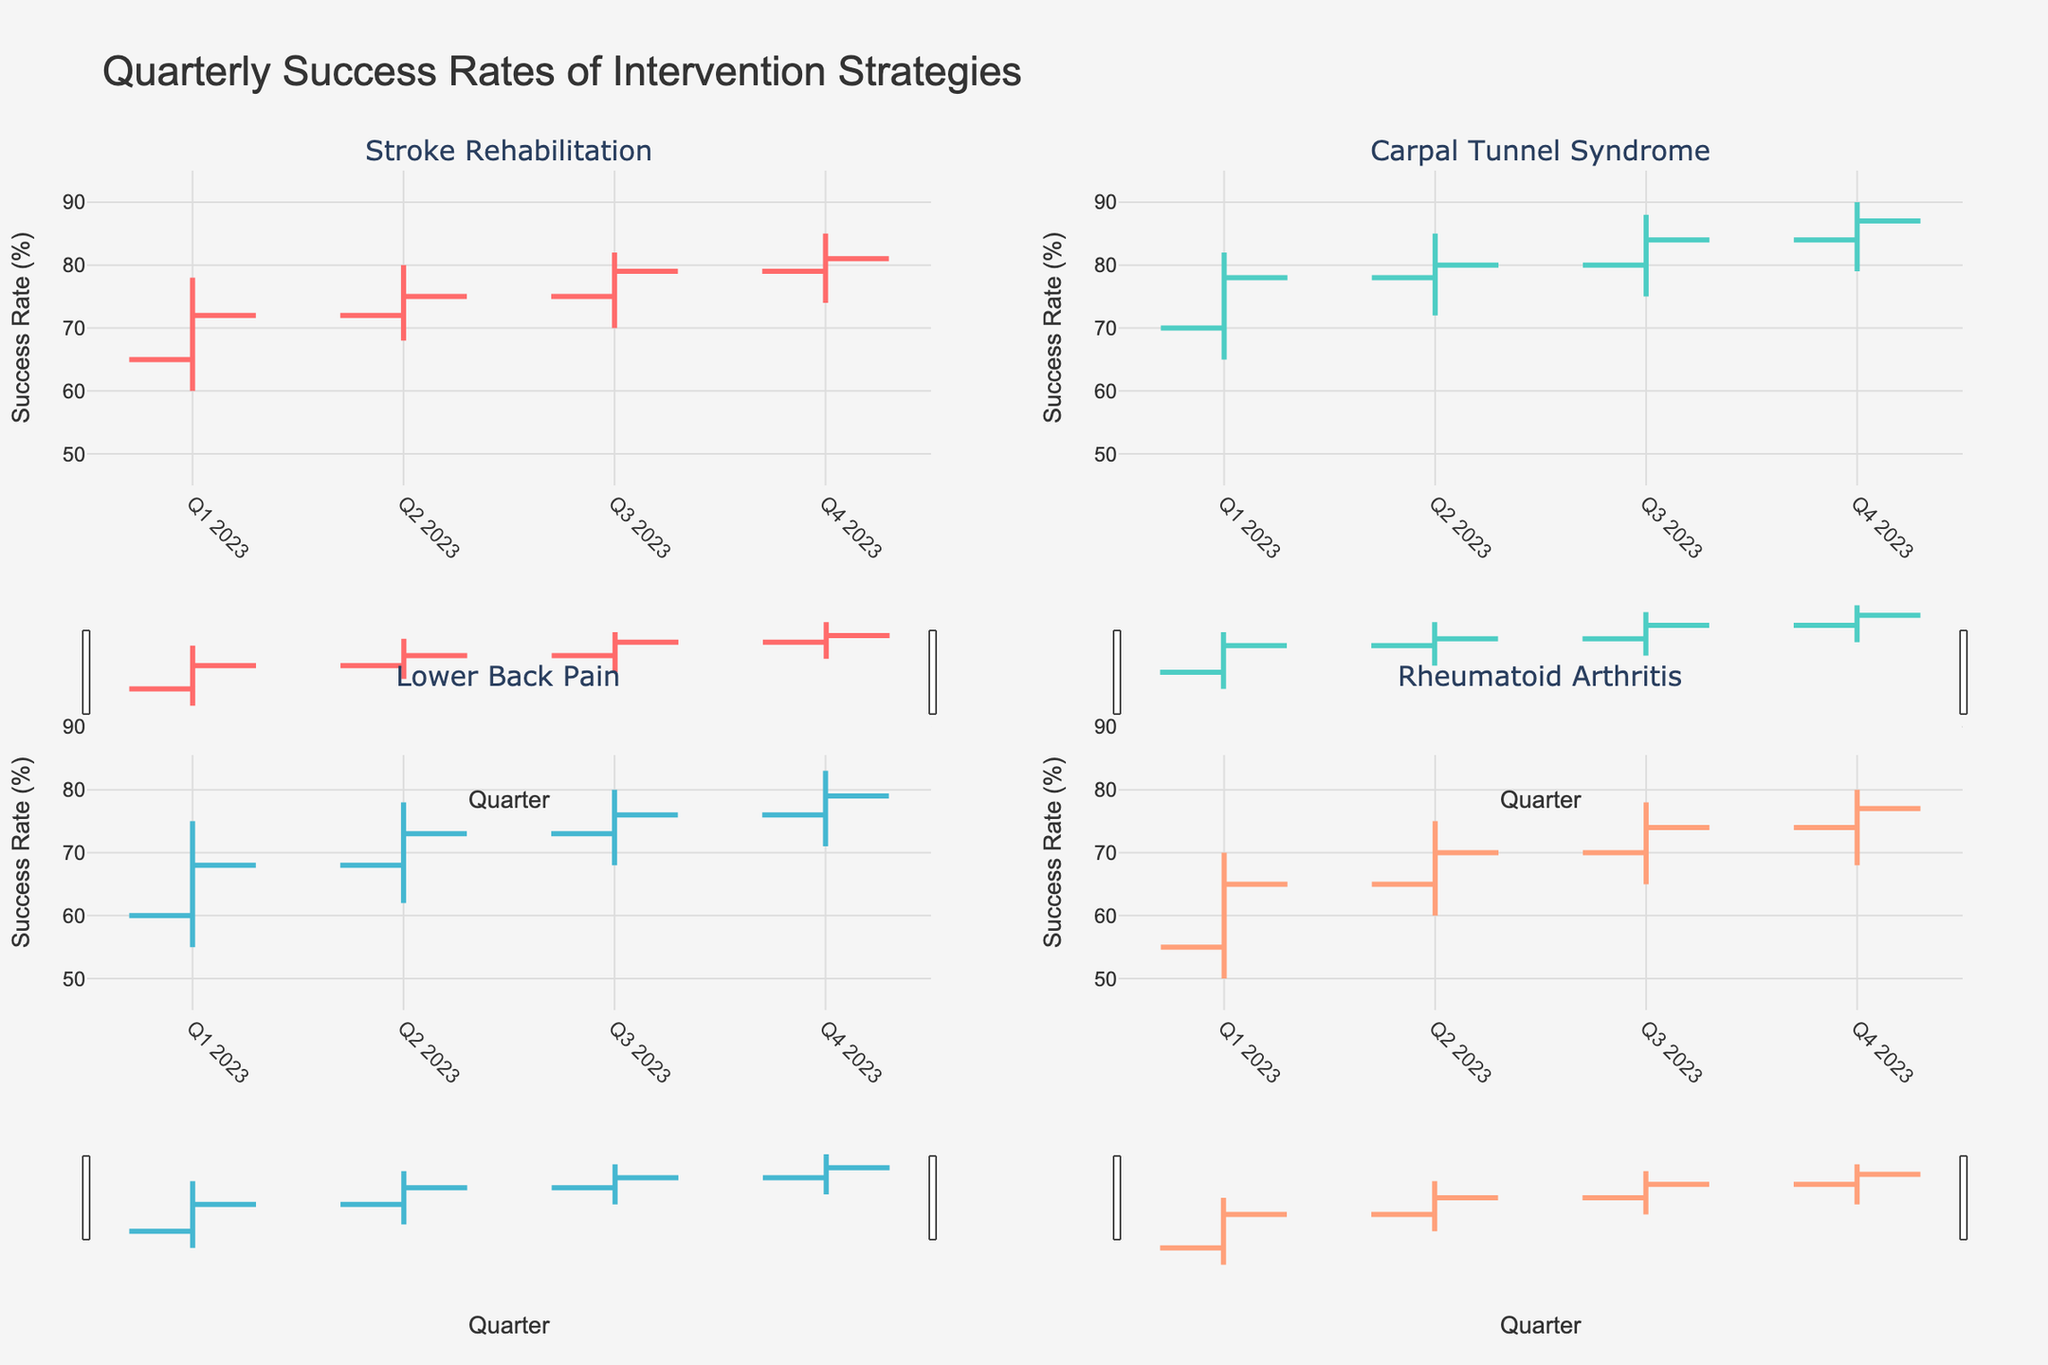What is the title of the figure? The title is displayed at the top of the figure. It reads "Quarterly Success Rates of Intervention Strategies".
Answer: Quarterly Success Rates of Intervention Strategies Which condition showed an increase in success rate every quarter throughout 2023? By examining each subplot, Stroke Rehabilitation (top-left) shows an increase in the "Close" value every quarter: 72, 75, 79, and 81.
Answer: Stroke Rehabilitation In which quarter did Carpal Tunnel Syndrome reach its highest success rate? In the Carpal Tunnel Syndrome subplot (top-right), the highest value on the "high" scale is in Q4 2023 (90).
Answer: Q4 2023 What was the success rate in Q2 2023 for Rheumatoid Arthritis? In the Rheumatoid Arthritis subplot (bottom-right), the success rate at Q2 2023 is found by looking at the "Close" value for that quarter, which is 70.
Answer: 70 In which quarter did Lower Back Pain have the highest increase in success rate compared to the previous quarter? Calculate the difference between successive quarters for Lower Back Pain (bottom-left). The highest increase is from Q1 to Q2 (73-68=5).
Answer: Q2 2023 Compare the success rates of Q4 2023 for both Stroke Rehabilitation and Carpal Tunnel Syndrome. Which one is higher? In Q4 2023, Stroke Rehabilitation's "Close" value is 81, while Carpal Tunnel Syndrome's is 87. Carpal Tunnel Syndrome's rate is higher.
Answer: Carpal Tunnel Syndrome What is the overall trend for all conditions from Q1 2023 to Q4 2023? For each condition in its respective quadrant, observe that the "Close" value increases from Q1 to Q4, showing an overall upward trend in success rates for all conditions.
Answer: Upward trend What is the average closing success rate for Rheumatoid Arthritis in 2023? The "Close" values for Rheumatoid Arthritis are 65, 70, 74, 77. The average is calculated as (65+70+74+77)/4 = 71.5.
Answer: 71.5 Which condition had the lowest success rate at any point in 2023, and what was the value? Check all "Low" values across the conditions. Rheumatoid Arthritis in Q1 2023 had the lowest "Low" value, which is 50.
Answer: Rheumatoid Arthritis, 50 